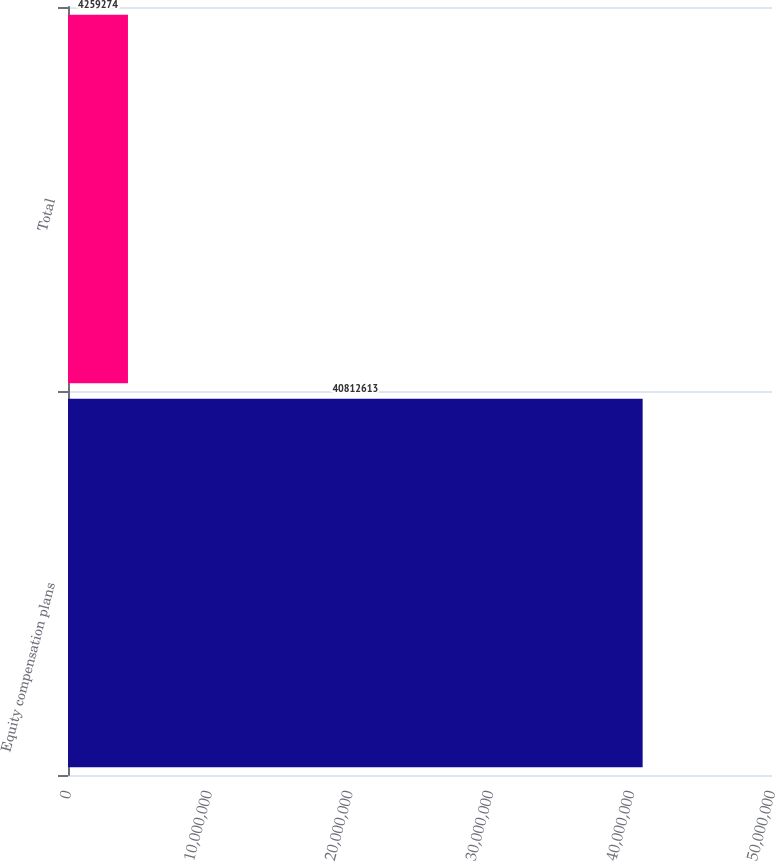<chart> <loc_0><loc_0><loc_500><loc_500><bar_chart><fcel>Equity compensation plans<fcel>Total<nl><fcel>4.08126e+07<fcel>4.25927e+06<nl></chart> 